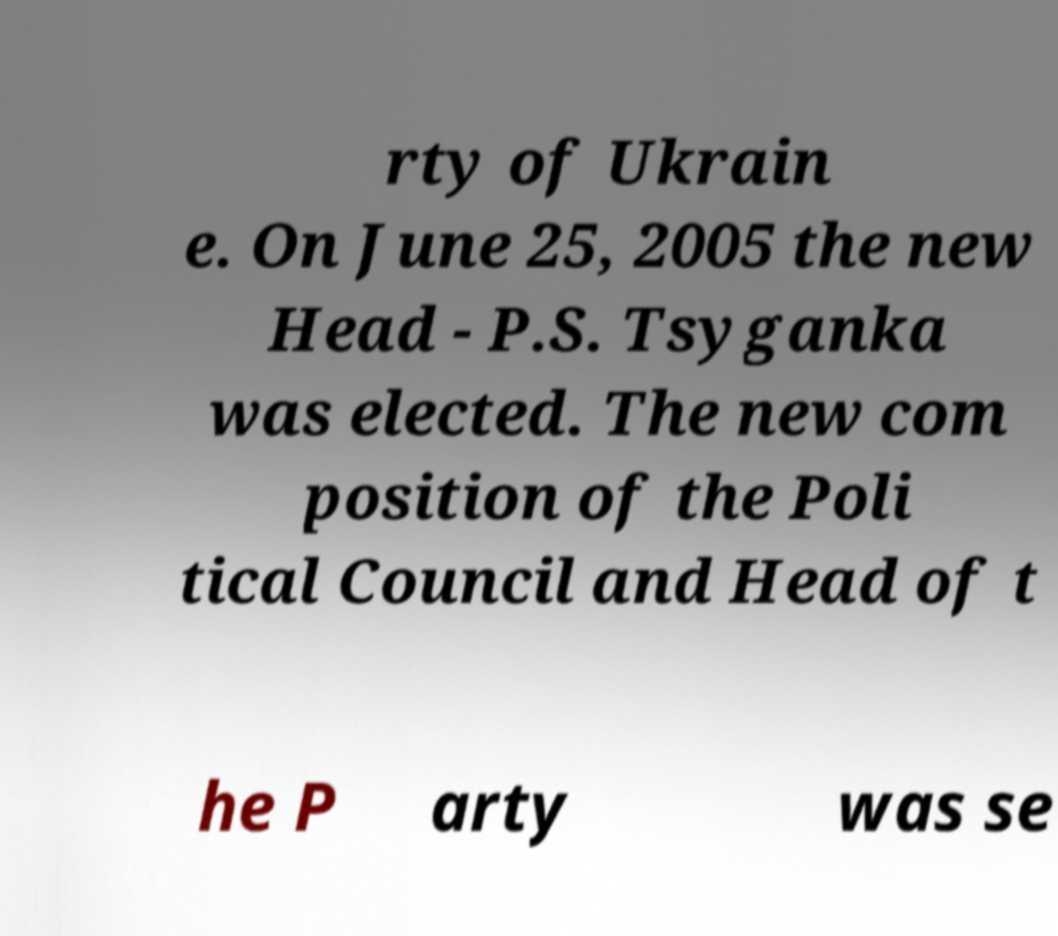Could you assist in decoding the text presented in this image and type it out clearly? rty of Ukrain e. On June 25, 2005 the new Head - P.S. Tsyganka was elected. The new com position of the Poli tical Council and Head of t he P arty was se 